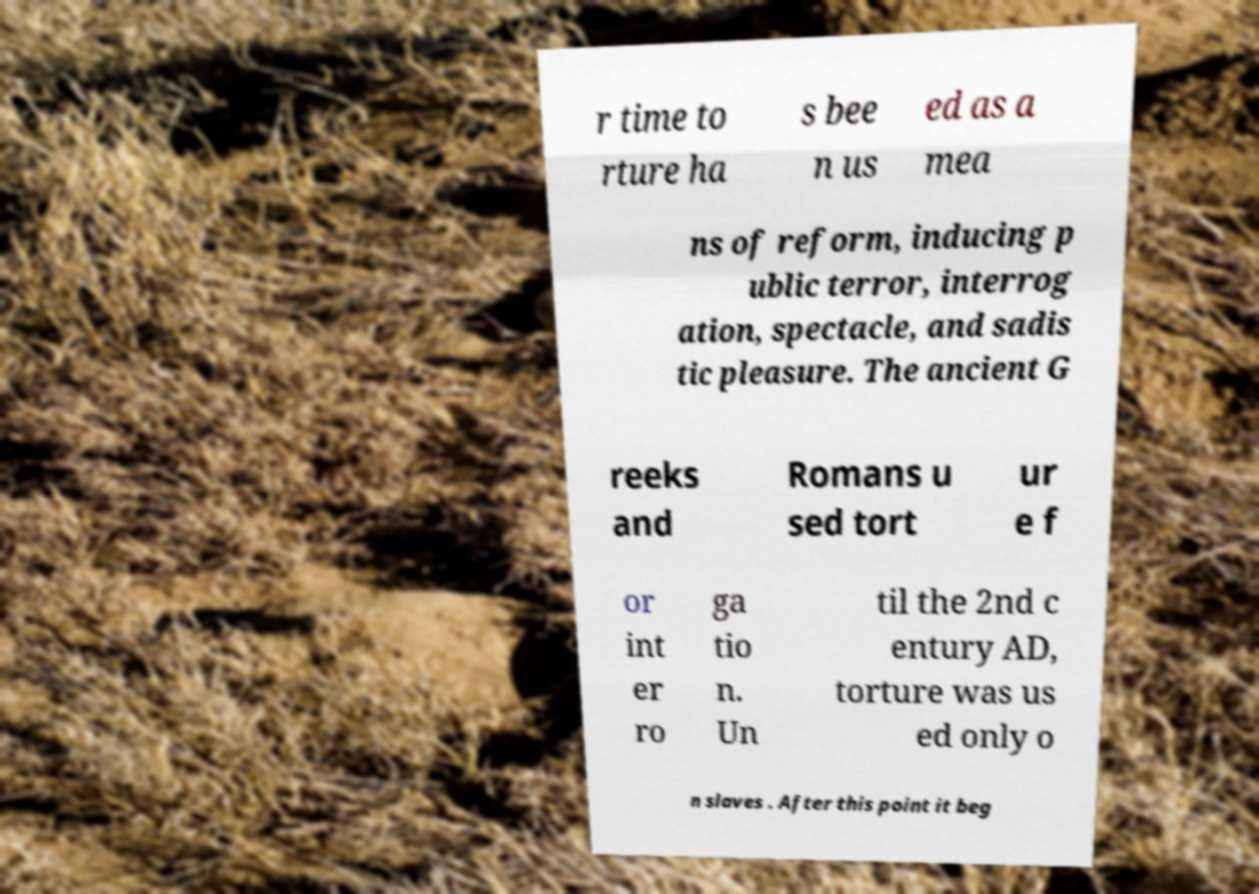What messages or text are displayed in this image? I need them in a readable, typed format. r time to rture ha s bee n us ed as a mea ns of reform, inducing p ublic terror, interrog ation, spectacle, and sadis tic pleasure. The ancient G reeks and Romans u sed tort ur e f or int er ro ga tio n. Un til the 2nd c entury AD, torture was us ed only o n slaves . After this point it beg 